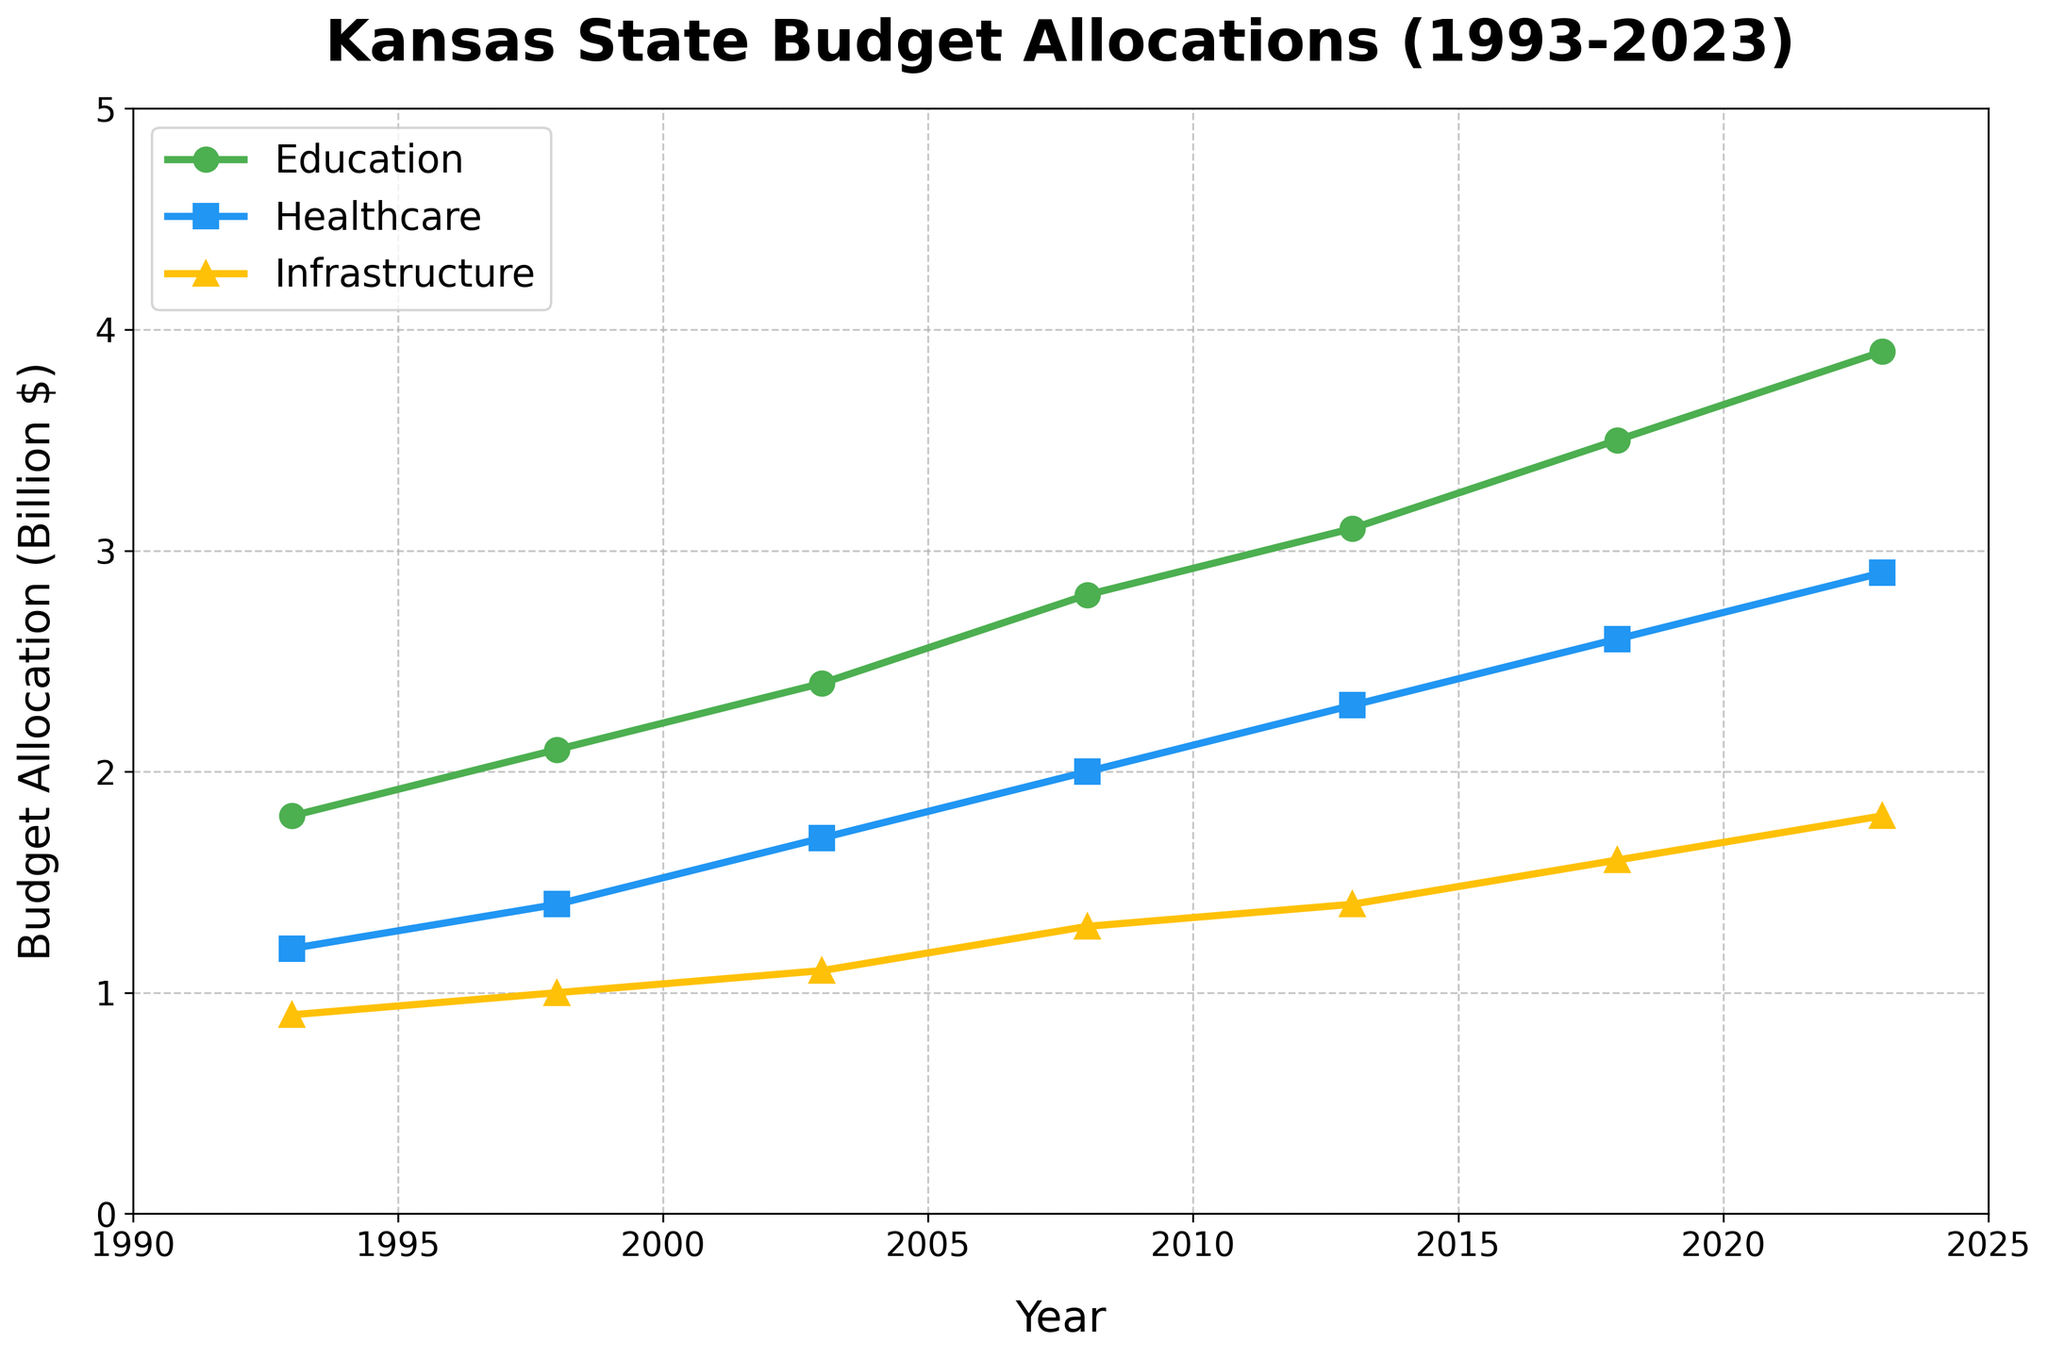Comparison questions:
1. Which sector received the highest budget allocation in 2023? The highest line at the far right of the chart represents the sector with the highest allocation. In 2023, the green line (Education) is the highest.
Answer: Education 2. By how much did the budget allocation for Healthcare increase from 1993 to 2023? Look at the Healthcare values for 1993 and 2023. Subtract the 1993 value from the 2023 value: 2.9 - 1.2.
Answer: 1.7 billion $ 3. Which sector had the least growth in budget allocation from 1993 to 2023? Compute the growth for each sector by subtracting the 1993 values from 2023 values for each sector. The sector with the smallest difference is Infrastructure (1.8 - 0.9 = 0.9).
Answer: Infrastructure 4. Between 2008 and 2018, which sector saw the largest increase in budget allocation? Calculate the increase for each sector between 2008 and 2018 and compare them. The largest increase is for Education (3.5 - 2.8 = 0.7).
Answer: Education Visual questions:
5. What color represents the Healthcare budget allocation in the figure? Identify the color of the line that represents the Healthcare sector in the chart.
Answer: Blue 6. Which marker shape represents the Infrastructure sector? Identify the shape used for the Infrastructure sector in the chart.
Answer: Triangle 7. Between which years did the Education sector see a noticeable increase without any periods of stagnation or decrease? Identify the segments of the green line (Education) on the chart where it continuously rises. It continuously rises from 1993 to 2023.
Answer: 1993 to 2023 Compositional questions:
8. What is the average budget allocation for Education over the entire period? Sum the Education values over all years and divide by the number of years: (1.8 + 2.1 + 2.4 + 2.8 + 3.1 + 3.5 + 3.9) / 7
Answer: 2.8 billion $ 9. What was the combined budget allocation for Infrastructure in 2003 and Healthcare in 2013? Sum the Infrastructure value in 2003 and the Healthcare value in 2013: 1.1 + 2.3.
Answer: 3.4 billion $ 10. What is the total increase in budget allocation for Infrastructure from 1993 to 2023? Subtract the Infrastructure value in 1993 from the one in 2023: 1.8 - 0.9.
Answer: 0.9 billion $ 